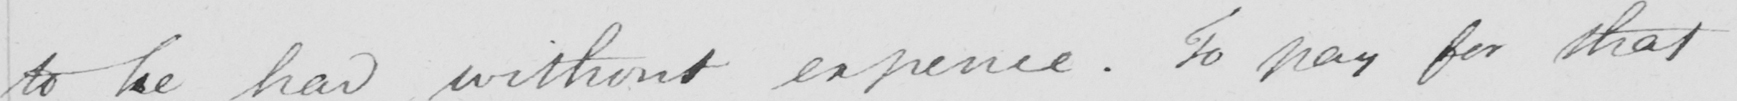What does this handwritten line say? to be had without expence . To pay for that 